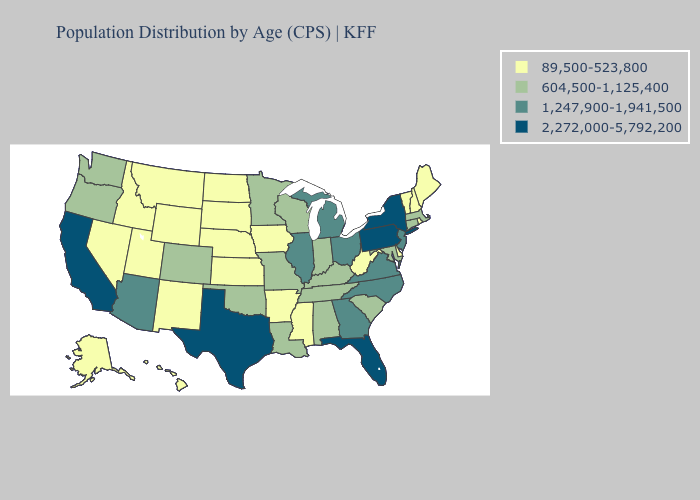What is the value of Oregon?
Quick response, please. 604,500-1,125,400. Does Iowa have a lower value than Kansas?
Answer briefly. No. Among the states that border Oklahoma , which have the lowest value?
Answer briefly. Arkansas, Kansas, New Mexico. Among the states that border Illinois , does Iowa have the lowest value?
Quick response, please. Yes. What is the highest value in the MidWest ?
Be succinct. 1,247,900-1,941,500. Name the states that have a value in the range 89,500-523,800?
Give a very brief answer. Alaska, Arkansas, Delaware, Hawaii, Idaho, Iowa, Kansas, Maine, Mississippi, Montana, Nebraska, Nevada, New Hampshire, New Mexico, North Dakota, Rhode Island, South Dakota, Utah, Vermont, West Virginia, Wyoming. Does Kentucky have a lower value than Louisiana?
Answer briefly. No. What is the value of New Hampshire?
Quick response, please. 89,500-523,800. What is the lowest value in the South?
Answer briefly. 89,500-523,800. Name the states that have a value in the range 604,500-1,125,400?
Short answer required. Alabama, Colorado, Connecticut, Indiana, Kentucky, Louisiana, Maryland, Massachusetts, Minnesota, Missouri, Oklahoma, Oregon, South Carolina, Tennessee, Washington, Wisconsin. What is the value of Illinois?
Keep it brief. 1,247,900-1,941,500. Does the map have missing data?
Short answer required. No. What is the lowest value in states that border Kentucky?
Keep it brief. 89,500-523,800. Is the legend a continuous bar?
Concise answer only. No. 